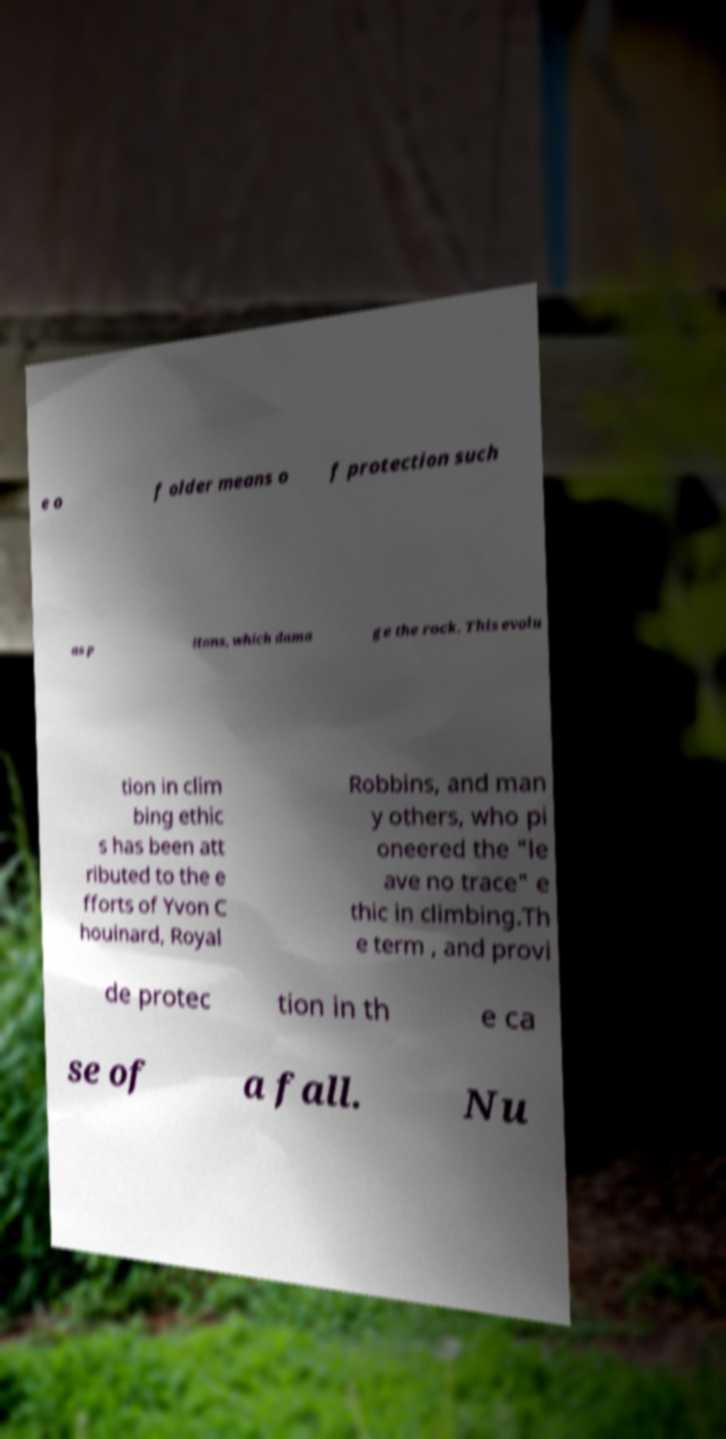Can you accurately transcribe the text from the provided image for me? e o f older means o f protection such as p itons, which dama ge the rock. This evolu tion in clim bing ethic s has been att ributed to the e fforts of Yvon C houinard, Royal Robbins, and man y others, who pi oneered the "le ave no trace" e thic in climbing.Th e term , and provi de protec tion in th e ca se of a fall. Nu 